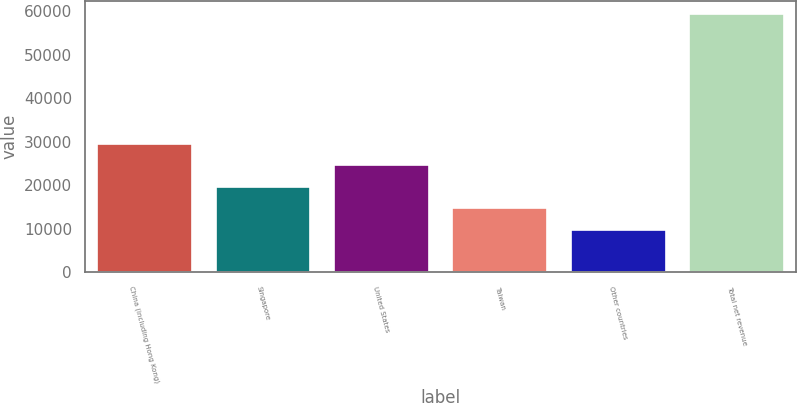<chart> <loc_0><loc_0><loc_500><loc_500><bar_chart><fcel>China (including Hong Kong)<fcel>Singapore<fcel>United States<fcel>Taiwan<fcel>Other countries<fcel>Total net revenue<nl><fcel>29586.8<fcel>19653.4<fcel>24620.1<fcel>14686.7<fcel>9720<fcel>59387<nl></chart> 